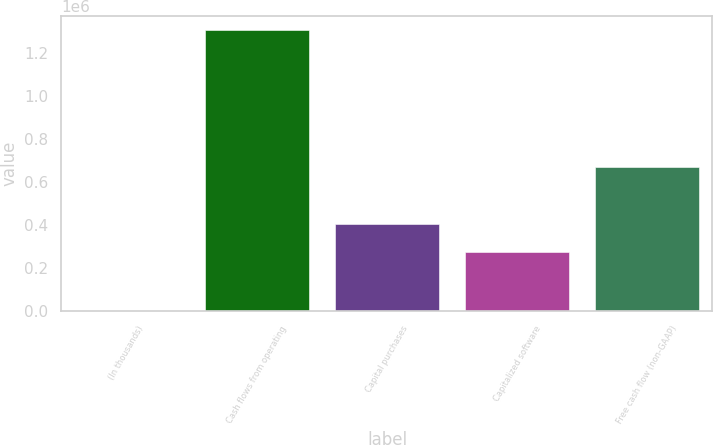Convert chart. <chart><loc_0><loc_0><loc_500><loc_500><bar_chart><fcel>(In thousands)<fcel>Cash flows from operating<fcel>Capital purchases<fcel>Capitalized software<fcel>Free cash flow (non-GAAP)<nl><fcel>2017<fcel>1.30768e+06<fcel>404714<fcel>274148<fcel>671444<nl></chart> 